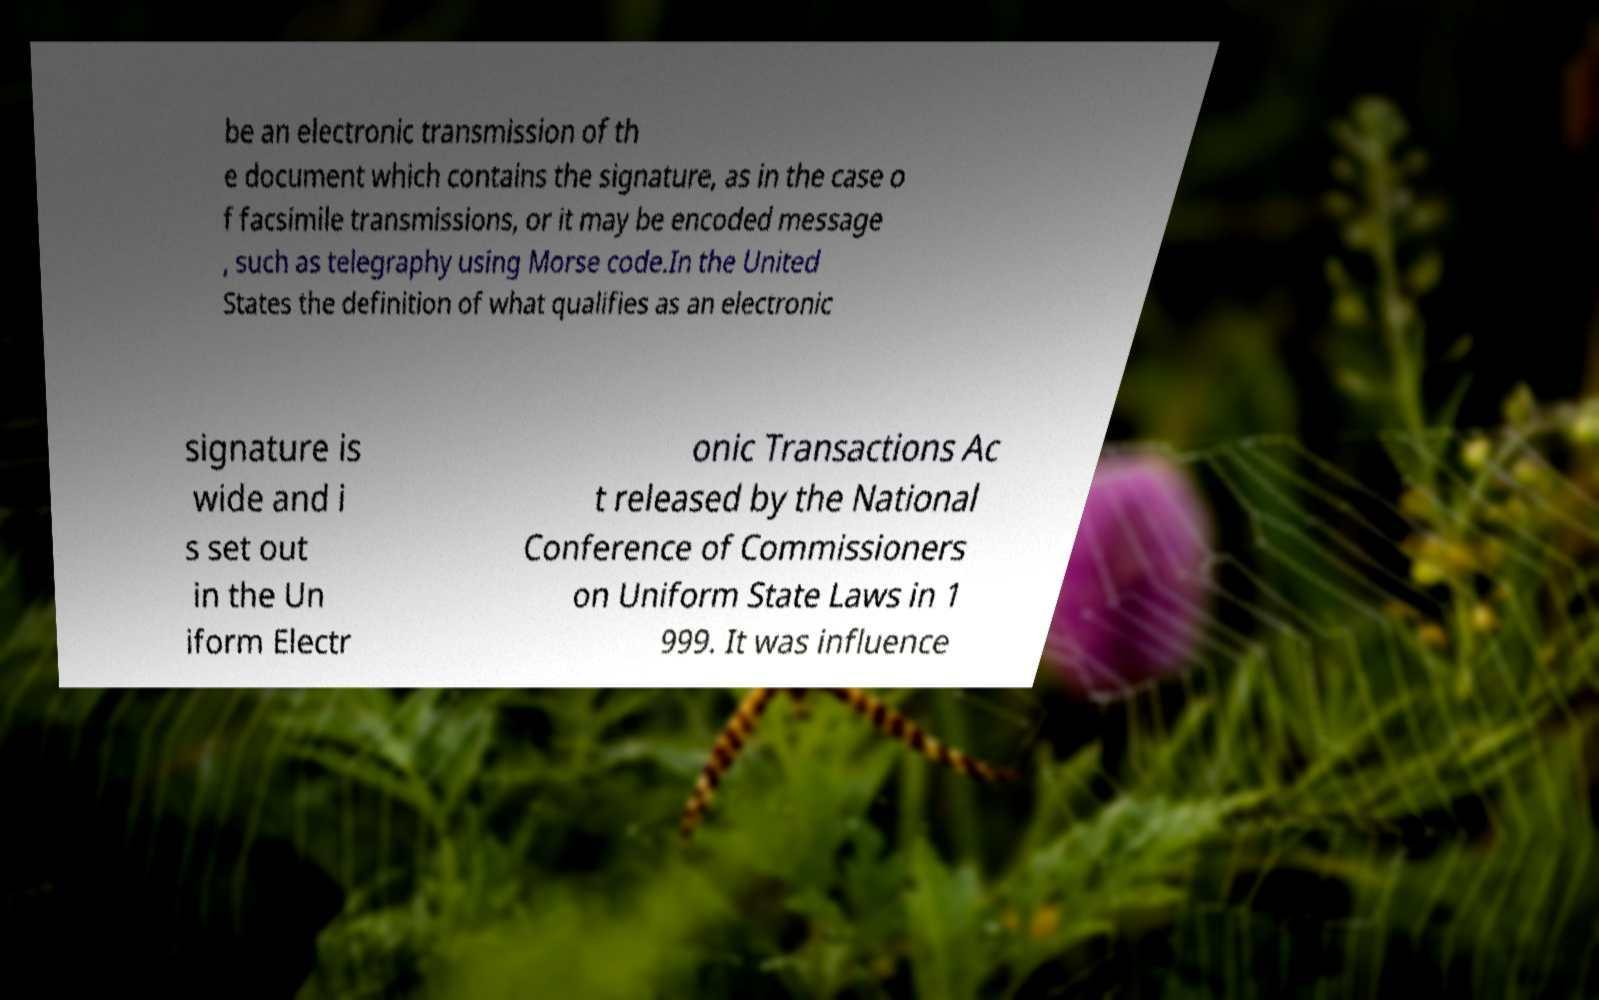For documentation purposes, I need the text within this image transcribed. Could you provide that? be an electronic transmission of th e document which contains the signature, as in the case o f facsimile transmissions, or it may be encoded message , such as telegraphy using Morse code.In the United States the definition of what qualifies as an electronic signature is wide and i s set out in the Un iform Electr onic Transactions Ac t released by the National Conference of Commissioners on Uniform State Laws in 1 999. It was influence 